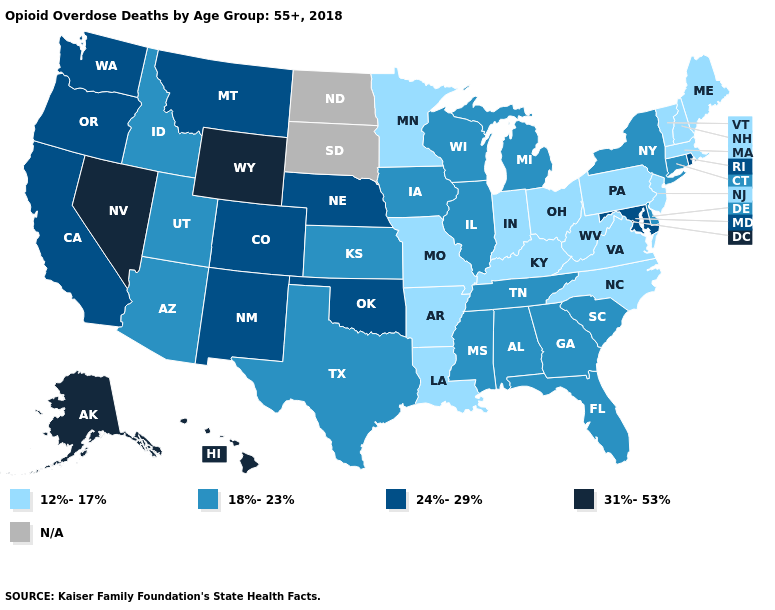Name the states that have a value in the range 24%-29%?
Short answer required. California, Colorado, Maryland, Montana, Nebraska, New Mexico, Oklahoma, Oregon, Rhode Island, Washington. What is the lowest value in states that border Maine?
Be succinct. 12%-17%. What is the value of Alabama?
Keep it brief. 18%-23%. What is the value of Indiana?
Concise answer only. 12%-17%. What is the value of Alaska?
Concise answer only. 31%-53%. Name the states that have a value in the range 18%-23%?
Quick response, please. Alabama, Arizona, Connecticut, Delaware, Florida, Georgia, Idaho, Illinois, Iowa, Kansas, Michigan, Mississippi, New York, South Carolina, Tennessee, Texas, Utah, Wisconsin. What is the highest value in states that border North Carolina?
Be succinct. 18%-23%. Which states have the highest value in the USA?
Be succinct. Alaska, Hawaii, Nevada, Wyoming. Among the states that border South Dakota , which have the lowest value?
Keep it brief. Minnesota. Name the states that have a value in the range N/A?
Concise answer only. North Dakota, South Dakota. Name the states that have a value in the range N/A?
Concise answer only. North Dakota, South Dakota. What is the lowest value in the USA?
Quick response, please. 12%-17%. Which states have the highest value in the USA?
Be succinct. Alaska, Hawaii, Nevada, Wyoming. Does Oklahoma have the lowest value in the South?
Write a very short answer. No. What is the value of Delaware?
Short answer required. 18%-23%. 